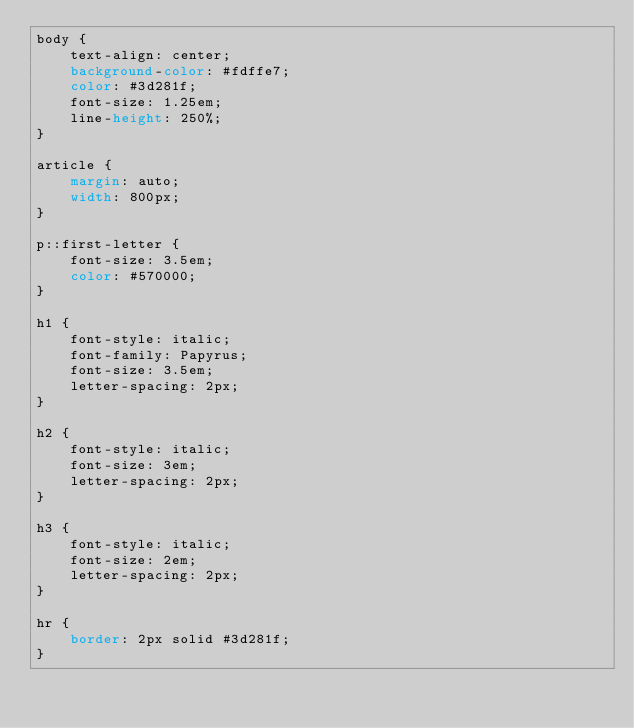<code> <loc_0><loc_0><loc_500><loc_500><_CSS_>body {
    text-align: center;
    background-color: #fdffe7;
    color: #3d281f;
    font-size: 1.25em;
    line-height: 250%;
}

article {
    margin: auto;
    width: 800px;
}

p::first-letter {
    font-size: 3.5em;
    color: #570000;
}

h1 {
    font-style: italic;
    font-family: Papyrus;
    font-size: 3.5em;
    letter-spacing: 2px;
}

h2 {
    font-style: italic;
    font-size: 3em;
    letter-spacing: 2px;
}

h3 {
    font-style: italic;
    font-size: 2em;
    letter-spacing: 2px;
}

hr {
    border: 2px solid #3d281f;
}</code> 